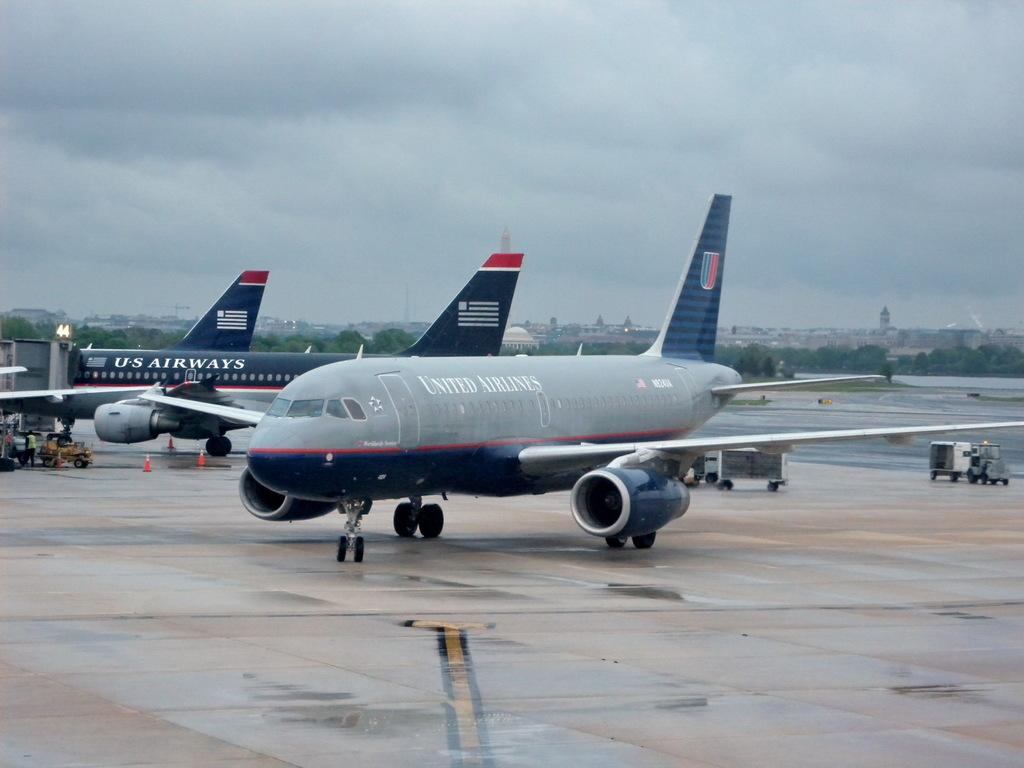<image>
Relay a brief, clear account of the picture shown. A grey and blue United Airlines is grounded next to a blue US Airways plane. 